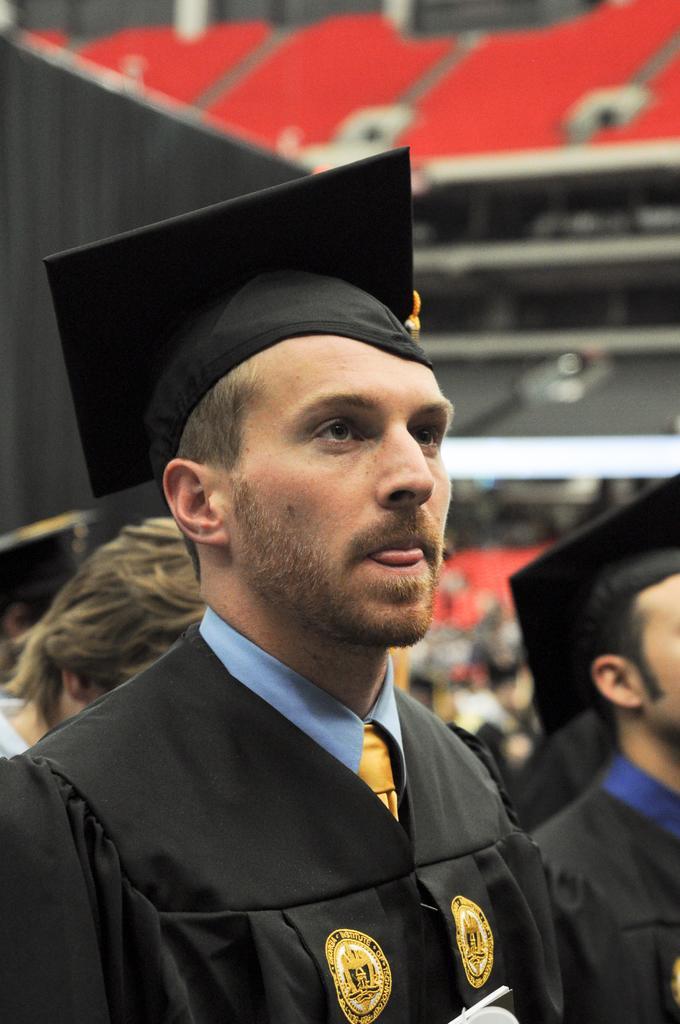In one or two sentences, can you explain what this image depicts? In this image, I can see two persons in academic dresses. On the left corner of the image, I can see the head of another person. There is a blurred background. 